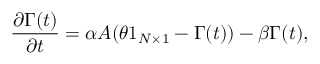<formula> <loc_0><loc_0><loc_500><loc_500>\frac { \partial \Gamma ( t ) } { \partial t } = \alpha A ( \theta 1 _ { N \times 1 } - \Gamma ( t ) ) - \beta \Gamma ( t ) ,</formula> 